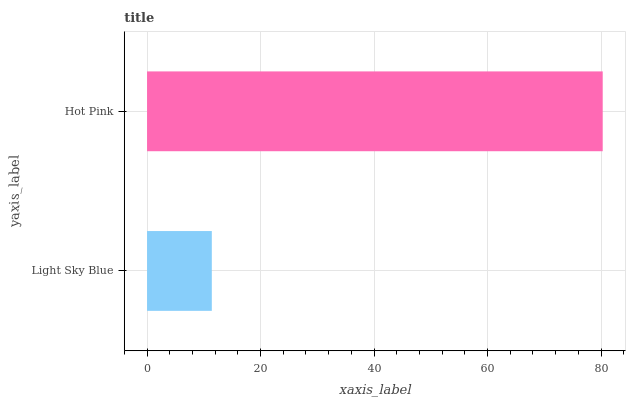Is Light Sky Blue the minimum?
Answer yes or no. Yes. Is Hot Pink the maximum?
Answer yes or no. Yes. Is Hot Pink the minimum?
Answer yes or no. No. Is Hot Pink greater than Light Sky Blue?
Answer yes or no. Yes. Is Light Sky Blue less than Hot Pink?
Answer yes or no. Yes. Is Light Sky Blue greater than Hot Pink?
Answer yes or no. No. Is Hot Pink less than Light Sky Blue?
Answer yes or no. No. Is Hot Pink the high median?
Answer yes or no. Yes. Is Light Sky Blue the low median?
Answer yes or no. Yes. Is Light Sky Blue the high median?
Answer yes or no. No. Is Hot Pink the low median?
Answer yes or no. No. 